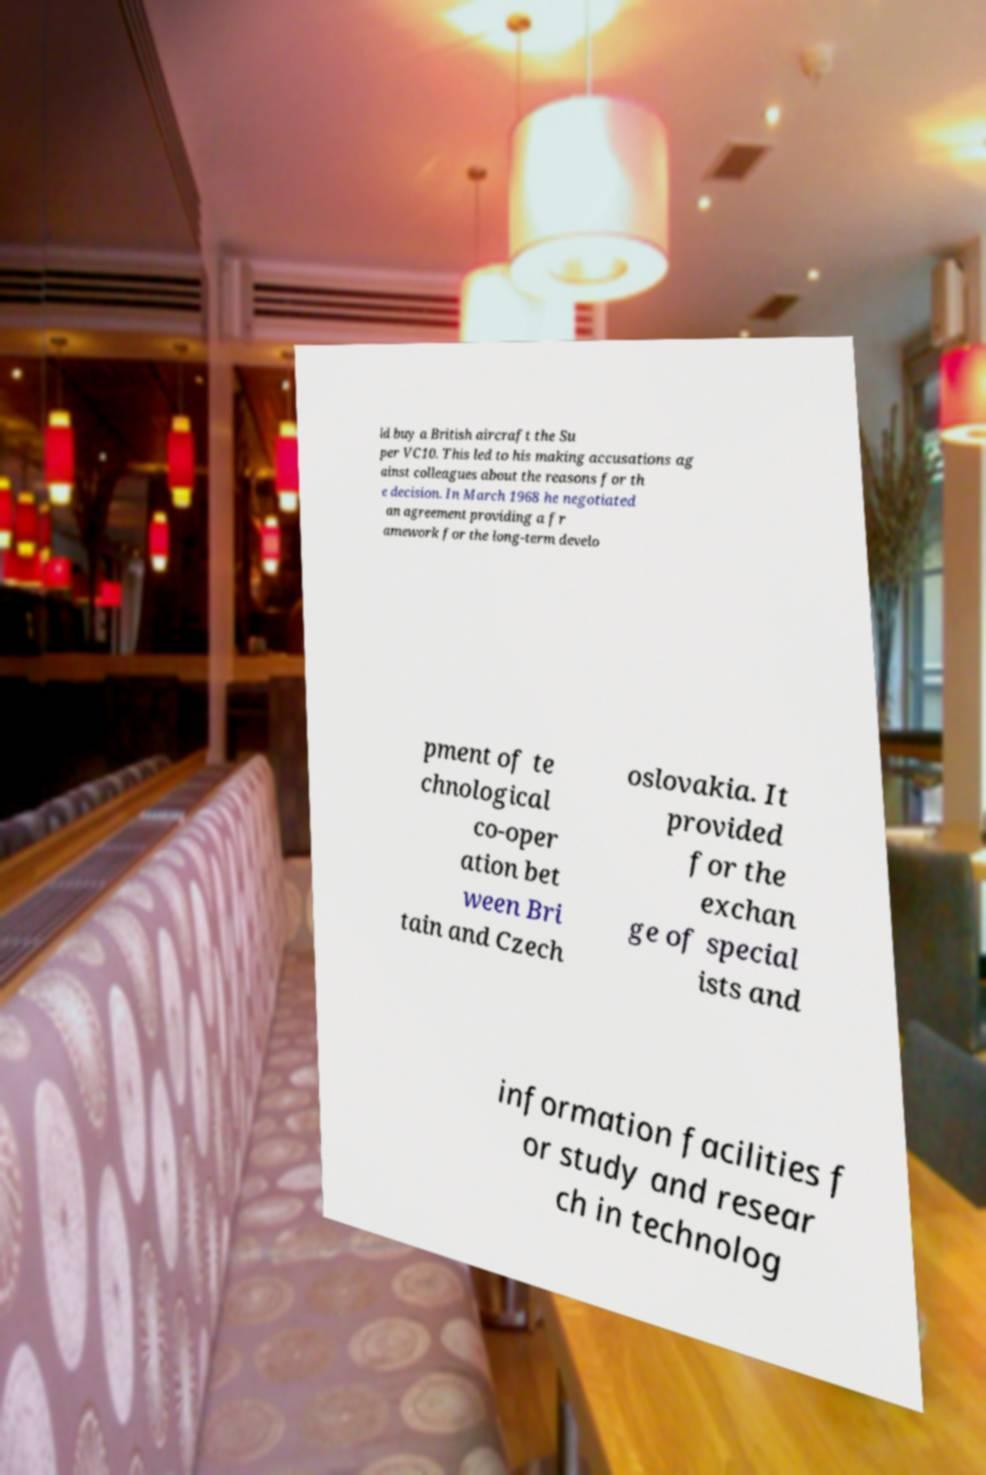Please identify and transcribe the text found in this image. ld buy a British aircraft the Su per VC10. This led to his making accusations ag ainst colleagues about the reasons for th e decision. In March 1968 he negotiated an agreement providing a fr amework for the long-term develo pment of te chnological co-oper ation bet ween Bri tain and Czech oslovakia. It provided for the exchan ge of special ists and information facilities f or study and resear ch in technolog 